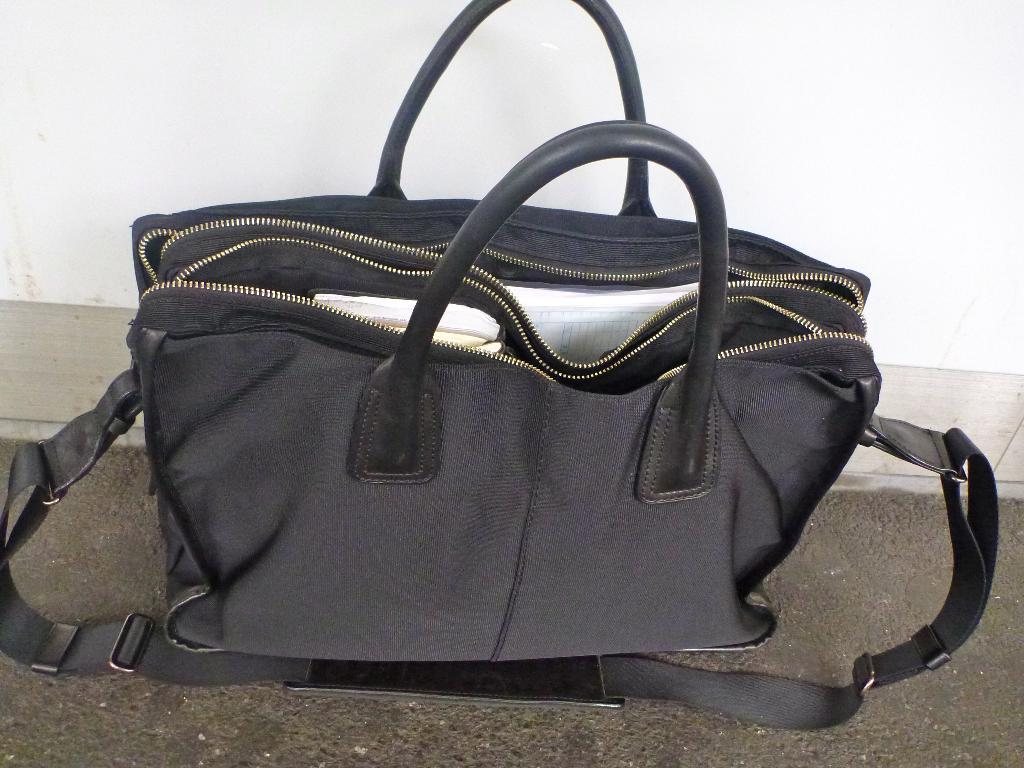What type of bag is visible in the image? There is a black handbag in the image. What is inside the handbag? There is a paper and tissues in the handbag. Where is the handbag located? The handbag is on the floor. What type of fear can be seen on the hand in the image? There is no hand or fear present in the image; it only features a black handbag with contents. 